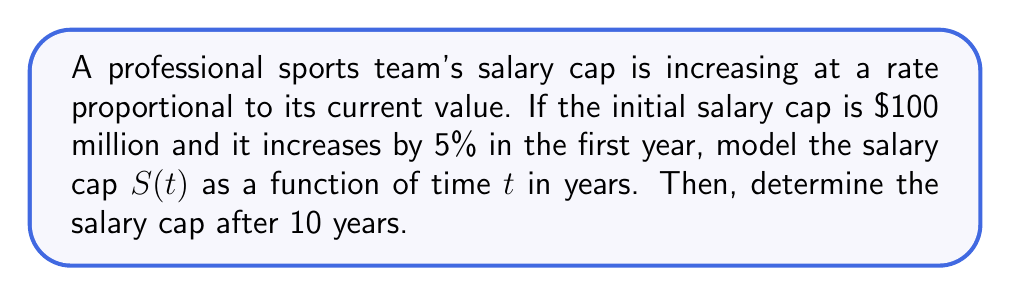Provide a solution to this math problem. Let's approach this problem step-by-step:

1) We're dealing with a situation where the rate of change of the salary cap is proportional to its current value. This scenario is modeled by a first-order differential equation:

   $$\frac{dS}{dt} = kS$$

   where $k$ is the proportionality constant.

2) We're given that the initial salary cap $S(0) = 100$ million dollars.

3) We're also told that the salary cap increases by 5% in the first year. This means:

   $$S(1) = 1.05 \times S(0) = 1.05 \times 100 = 105$$

4) The general solution to the differential equation $\frac{dS}{dt} = kS$ is:

   $$S(t) = S(0)e^{kt}$$

5) To find $k$, we can use the information about the first year:

   $$105 = 100e^k$$
   $$\ln(1.05) = k$$
   $$k \approx 0.0488$$

6) Now we have our complete model:

   $$S(t) = 100e^{0.0488t}$$

7) To find the salary cap after 10 years, we simply plug in $t = 10$:

   $$S(10) = 100e^{0.0488 \times 10} \approx 162.89$$

Therefore, after 10 years, the salary cap will be approximately $162.89 million.
Answer: $S(t) = 100e^{0.0488t}$ million dollars; After 10 years, $S(10) \approx 162.89$ million dollars 